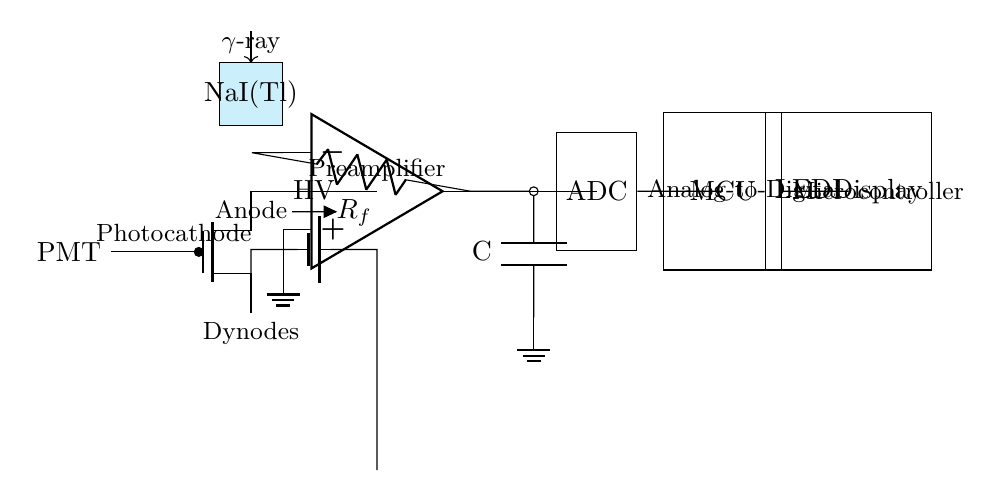What is the primary component for gamma-ray detection? The primary detector in this circuit is the Photomultiplier Tube (PMT), which is indicated at the leftmost part of the circuit diagram. It is responsible for converting incident gamma rays into an electrical signal.
Answer: Photomultiplier Tube What material is used in the scintillation crystal? The scintillation crystal used in this circuit is Sodium Iodide doped with Thallium, denoted as NaI(Tl). It is depicted in the circuit diagram as a rectangular block.
Answer: Sodium Iodide (NaI(Tl)) What component shapes the pulse from the PMT? The op-amp acts as the preamplifier, which is directly connected to the PMT. It is responsible for shaping the pulse generated by the PMT before further processing.
Answer: Preamplifier How does the ADC connect to the circuit? The ADC connects directly to the output of the op-amp, capturing the shaped signal for digitization. This connection is shown as a line leading to the ADC component in the circuit diagram.
Answer: Directly after the op-amp Which component is responsible for displaying the output? The LED Display, positioned at the end of the circuit, is responsible for visually representing the output data processed by the microcontroller.
Answer: LED Display What is the role of the high voltage supply? The high voltage supply provides the necessary voltage to the PMT, ensuring it operates effectively to detect gamma rays. This connection is depicted in the circuit by a battery symbol leading to the PMT.
Answer: Providing voltage to the PMT What component is used for voltage regulation in the pulse shaping stage? The component used for voltage regulation in the pulse shaping stage is a capacitor, labeled as C. It is connected to the output of the op-amp to filter and smooth the signal.
Answer: Capacitor 